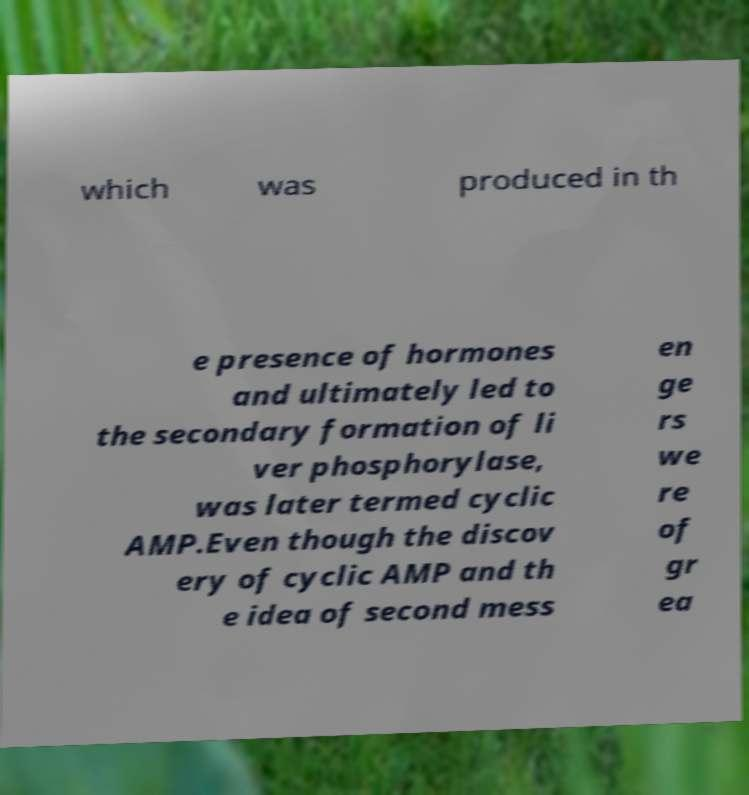What messages or text are displayed in this image? I need them in a readable, typed format. which was produced in th e presence of hormones and ultimately led to the secondary formation of li ver phosphorylase, was later termed cyclic AMP.Even though the discov ery of cyclic AMP and th e idea of second mess en ge rs we re of gr ea 